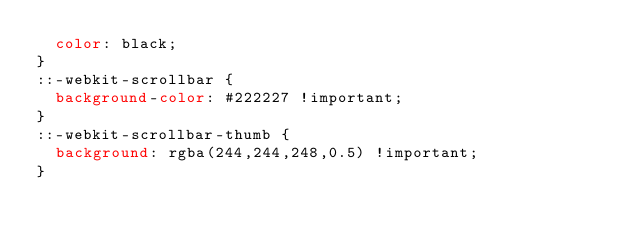Convert code to text. <code><loc_0><loc_0><loc_500><loc_500><_CSS_>  color: black;
}
::-webkit-scrollbar {
  background-color: #222227 !important;
}
::-webkit-scrollbar-thumb {
  background: rgba(244,244,248,0.5) !important;
}
</code> 